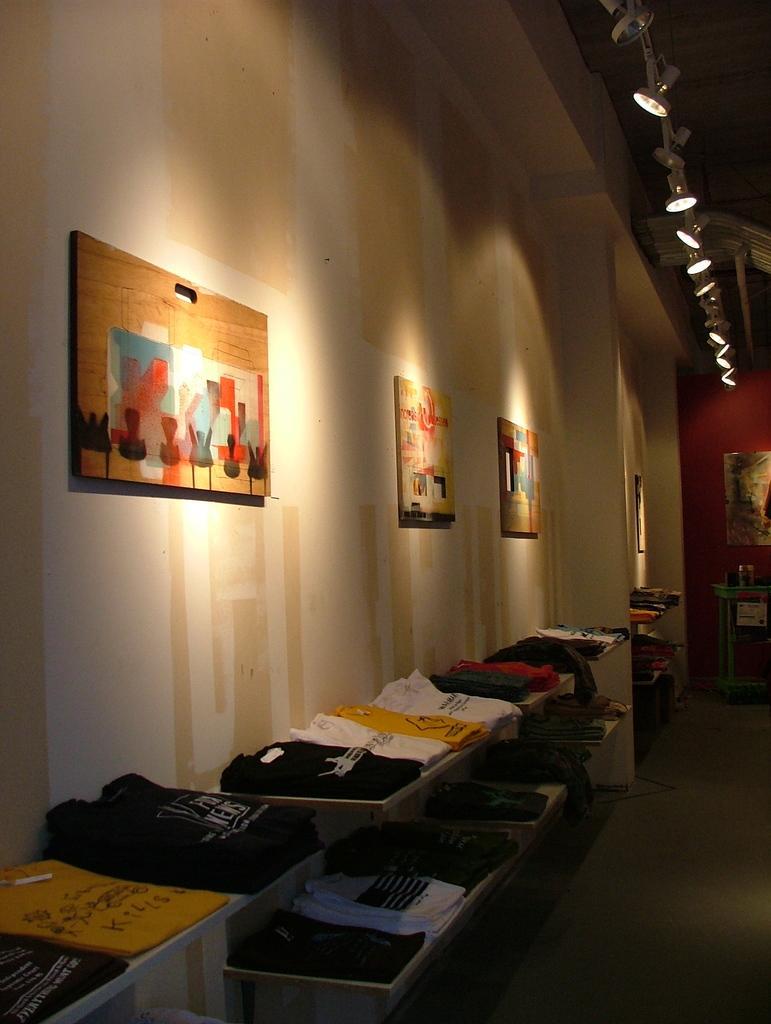In one or two sentences, can you explain what this image depicts? In this image I can see there is a rack. On the rack there are clothes. And there is a table, on the table there are bottles and few objects. And there is a wall, to that wall there are wooden frames attached to it. And at the top there is are lights. 